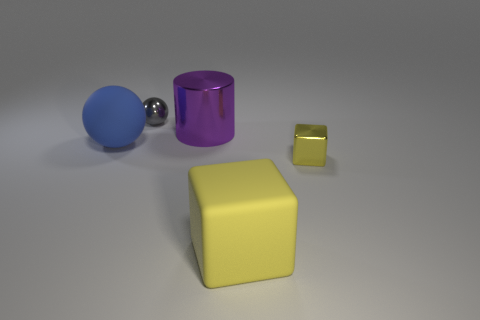Add 2 green shiny balls. How many objects exist? 7 Subtract all cubes. How many objects are left? 3 Add 1 big yellow rubber blocks. How many big yellow rubber blocks exist? 2 Subtract 0 gray cylinders. How many objects are left? 5 Subtract all tiny brown things. Subtract all purple objects. How many objects are left? 4 Add 2 rubber things. How many rubber things are left? 4 